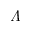<formula> <loc_0><loc_0><loc_500><loc_500>\varLambda</formula> 